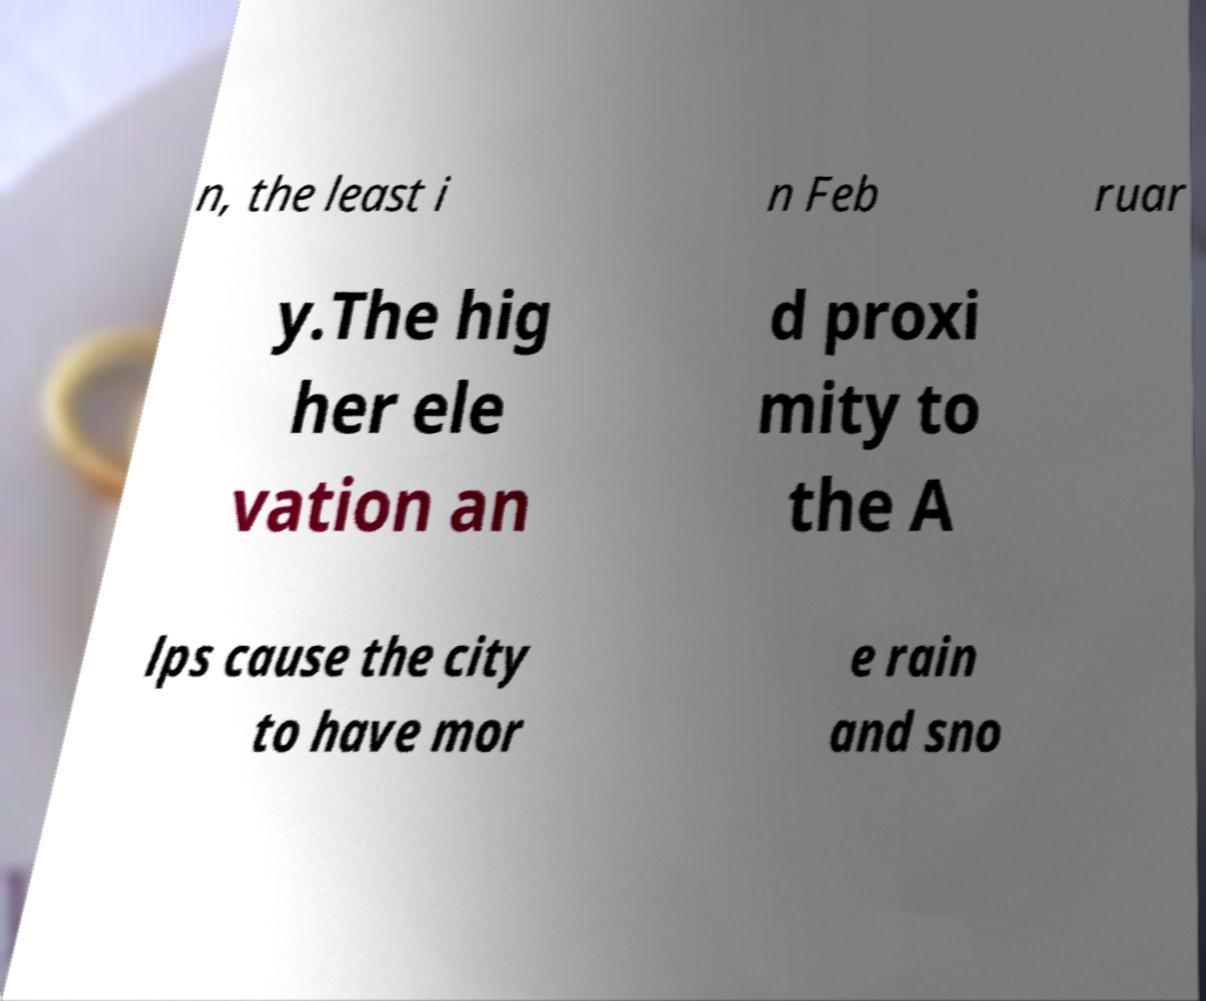Can you accurately transcribe the text from the provided image for me? n, the least i n Feb ruar y.The hig her ele vation an d proxi mity to the A lps cause the city to have mor e rain and sno 